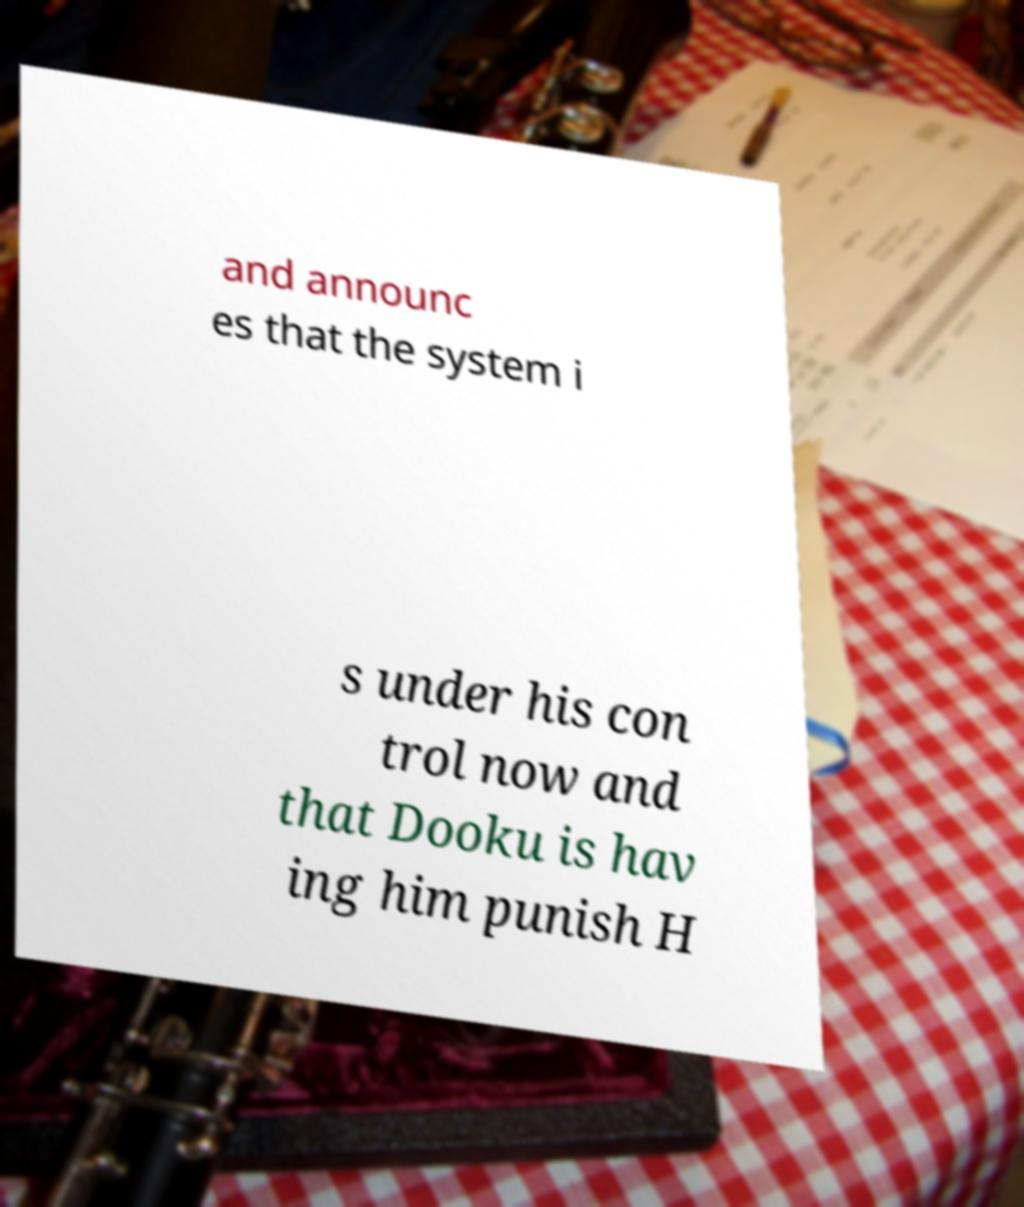Can you accurately transcribe the text from the provided image for me? and announc es that the system i s under his con trol now and that Dooku is hav ing him punish H 